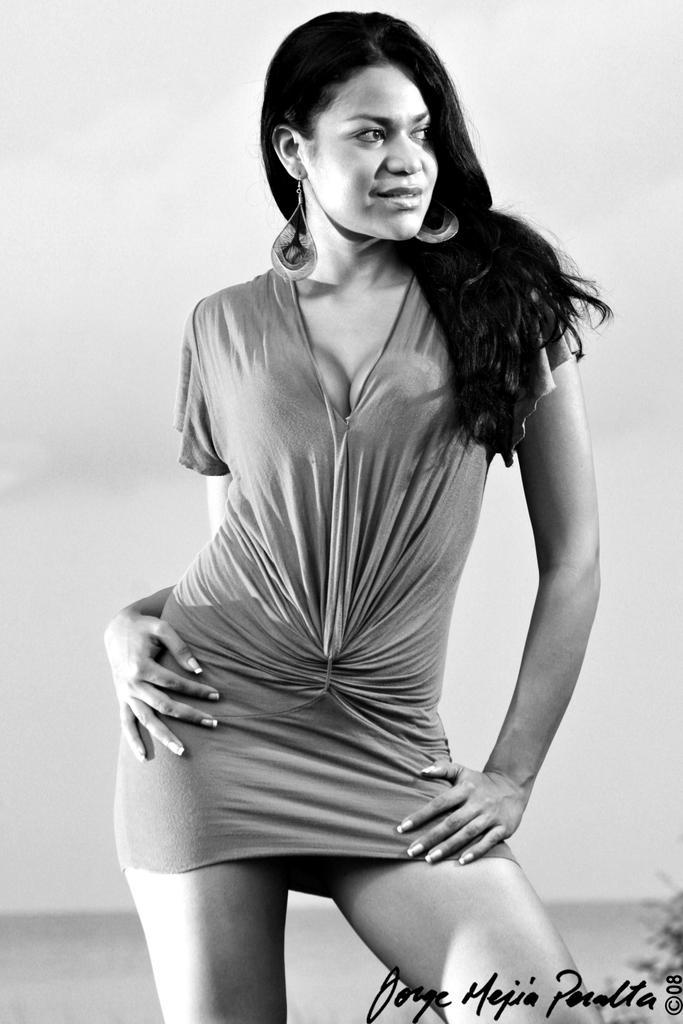In one or two sentences, can you explain what this image depicts? This is a black and white picture of a lady wearing a dress and earrings. On the right corner there is a watermark. 